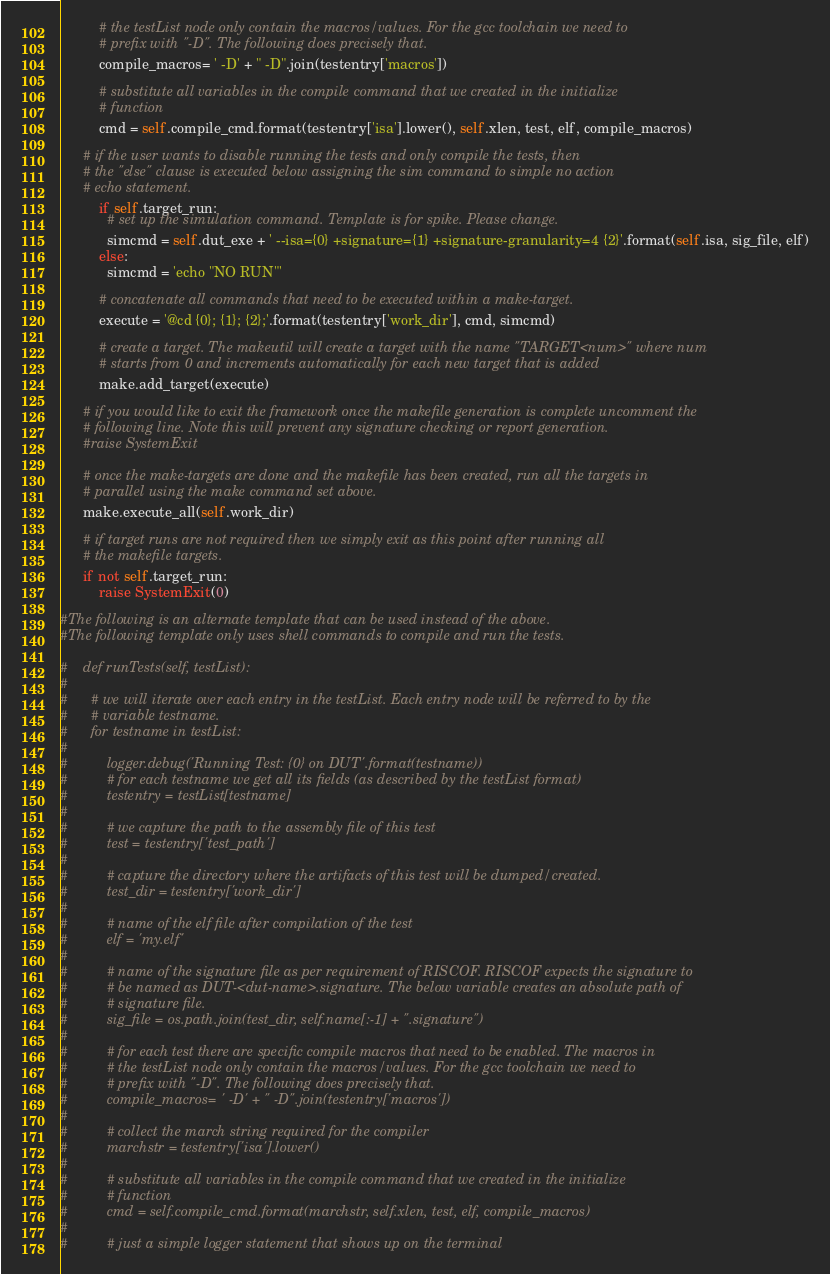<code> <loc_0><loc_0><loc_500><loc_500><_Python_>          # the testList node only contain the macros/values. For the gcc toolchain we need to
          # prefix with "-D". The following does precisely that.
          compile_macros= ' -D' + " -D".join(testentry['macros'])

          # substitute all variables in the compile command that we created in the initialize
          # function
          cmd = self.compile_cmd.format(testentry['isa'].lower(), self.xlen, test, elf, compile_macros)

	  # if the user wants to disable running the tests and only compile the tests, then
	  # the "else" clause is executed below assigning the sim command to simple no action
	  # echo statement.
          if self.target_run:
            # set up the simulation command. Template is for spike. Please change.
            simcmd = self.dut_exe + ' --isa={0} +signature={1} +signature-granularity=4 {2}'.format(self.isa, sig_file, elf)
          else:
            simcmd = 'echo "NO RUN"'

          # concatenate all commands that need to be executed within a make-target.
          execute = '@cd {0}; {1}; {2};'.format(testentry['work_dir'], cmd, simcmd)

          # create a target. The makeutil will create a target with the name "TARGET<num>" where num
          # starts from 0 and increments automatically for each new target that is added
          make.add_target(execute)

      # if you would like to exit the framework once the makefile generation is complete uncomment the
      # following line. Note this will prevent any signature checking or report generation.
      #raise SystemExit

      # once the make-targets are done and the makefile has been created, run all the targets in
      # parallel using the make command set above.
      make.execute_all(self.work_dir)

      # if target runs are not required then we simply exit as this point after running all
      # the makefile targets.
      if not self.target_run:
          raise SystemExit(0)

#The following is an alternate template that can be used instead of the above.
#The following template only uses shell commands to compile and run the tests.

#    def runTests(self, testList):
#
#      # we will iterate over each entry in the testList. Each entry node will be referred to by the
#      # variable testname.
#      for testname in testList:
#
#          logger.debug('Running Test: {0} on DUT'.format(testname))
#          # for each testname we get all its fields (as described by the testList format)
#          testentry = testList[testname]
#
#          # we capture the path to the assembly file of this test
#          test = testentry['test_path']
#
#          # capture the directory where the artifacts of this test will be dumped/created.
#          test_dir = testentry['work_dir']
#
#          # name of the elf file after compilation of the test
#          elf = 'my.elf'
#
#          # name of the signature file as per requirement of RISCOF. RISCOF expects the signature to
#          # be named as DUT-<dut-name>.signature. The below variable creates an absolute path of
#          # signature file.
#          sig_file = os.path.join(test_dir, self.name[:-1] + ".signature")
#
#          # for each test there are specific compile macros that need to be enabled. The macros in
#          # the testList node only contain the macros/values. For the gcc toolchain we need to
#          # prefix with "-D". The following does precisely that.
#          compile_macros= ' -D' + " -D".join(testentry['macros'])
#
#          # collect the march string required for the compiler
#          marchstr = testentry['isa'].lower()
#
#          # substitute all variables in the compile command that we created in the initialize
#          # function
#          cmd = self.compile_cmd.format(marchstr, self.xlen, test, elf, compile_macros)
#
#          # just a simple logger statement that shows up on the terminal</code> 